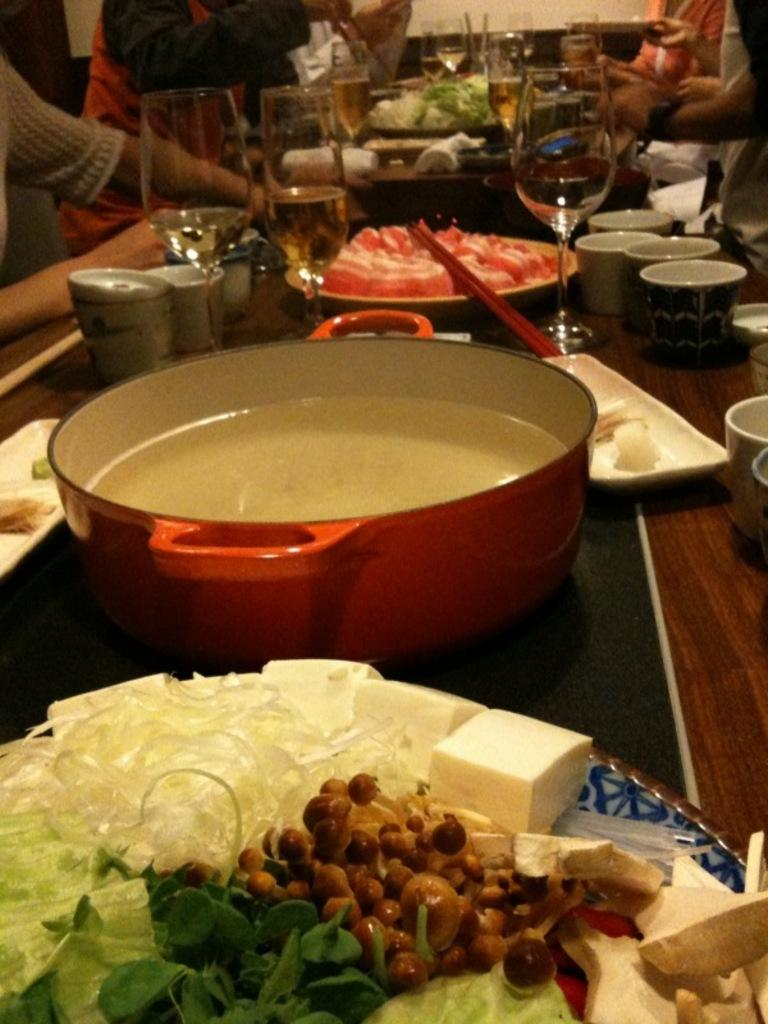What type of glassware is visible in the image? There are wine glasses in the image. What other type of tableware can be seen in the image? There are cups in the image. What utensils are present in the image? Chopsticks are in the image. What is on the plates in the image? There are food items on plates in the image. What is contained in the vessel in the image? There is a vessel containing liquid in the image. What else is on the table in the image? There are other objects on the table in the image. Who is present in the image? There is a group of people in the image. Where is the jelly located in the image? There is no jelly present in the image. What type of frog can be seen interacting with the food items in the image? There is no frog present in the image. What is the purpose of the bomb in the image? There is no bomb present in the image. 